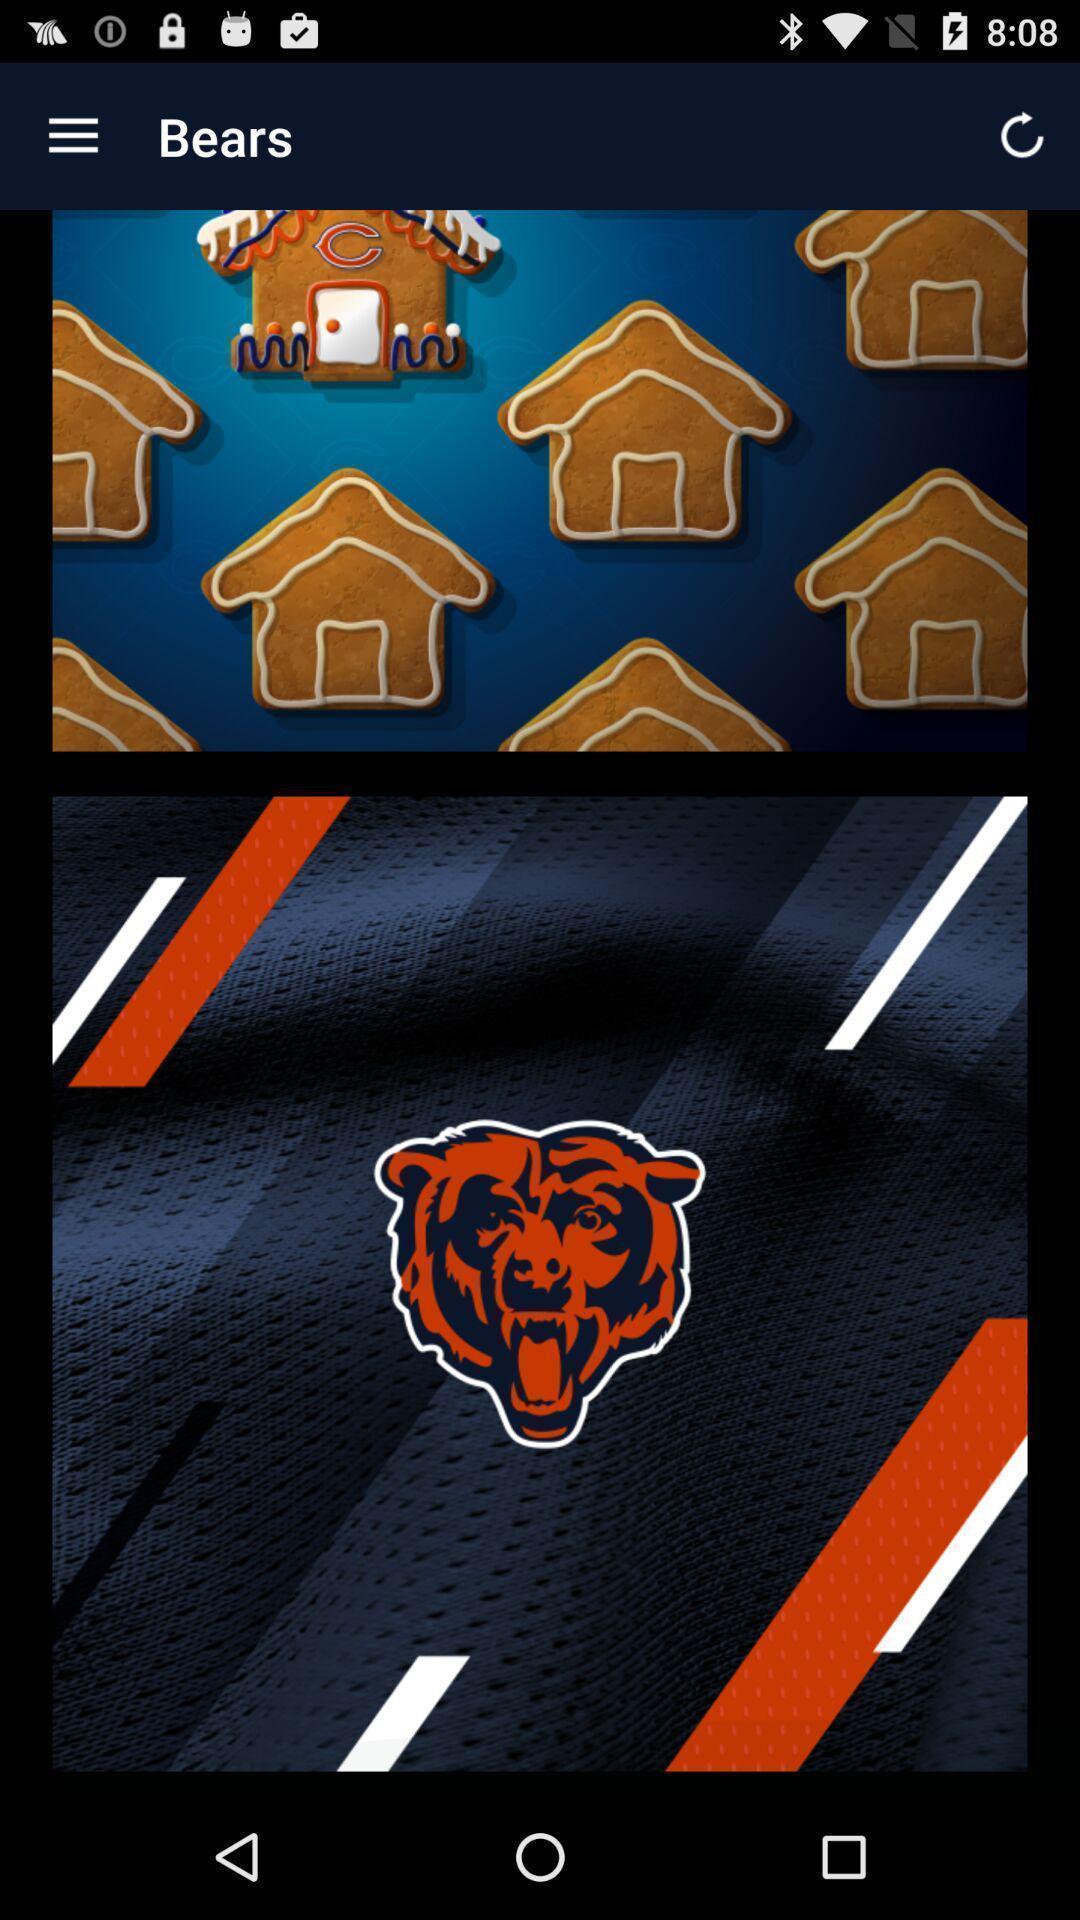Summarize the main components in this picture. Screen shows multiple images in a gaming application. 